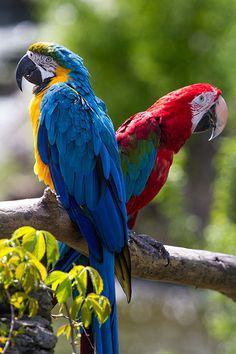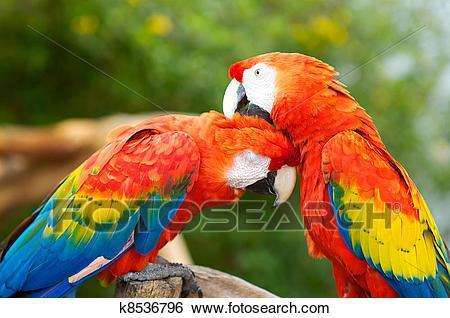The first image is the image on the left, the second image is the image on the right. Evaluate the accuracy of this statement regarding the images: "There are at most three scarlet macaws..". Is it true? Answer yes or no. No. The first image is the image on the left, the second image is the image on the right. Considering the images on both sides, is "The image on the right contains one parrot with blue wings closest to the left of the image." valid? Answer yes or no. No. 